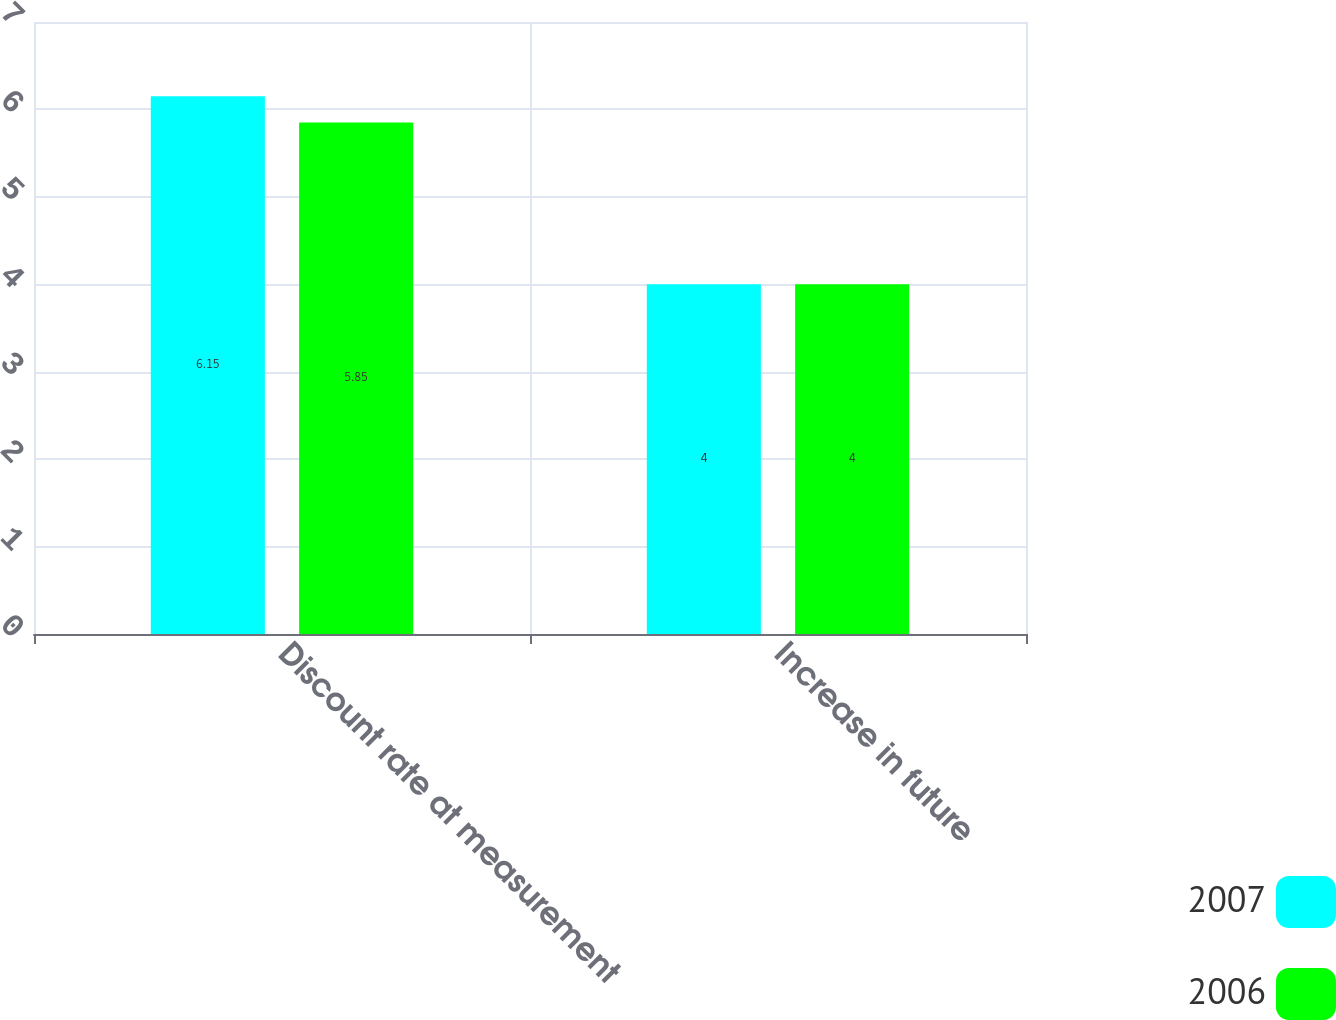Convert chart to OTSL. <chart><loc_0><loc_0><loc_500><loc_500><stacked_bar_chart><ecel><fcel>Discount rate at measurement<fcel>Increase in future<nl><fcel>2007<fcel>6.15<fcel>4<nl><fcel>2006<fcel>5.85<fcel>4<nl></chart> 